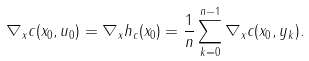<formula> <loc_0><loc_0><loc_500><loc_500>\nabla _ { x } c ( x _ { 0 } , u _ { 0 } ) = \nabla _ { x } h _ { c } ( x _ { 0 } ) = \frac { 1 } { n } \sum _ { k = 0 } ^ { n - 1 } \nabla _ { x } c ( x _ { 0 } , y _ { k } ) .</formula> 